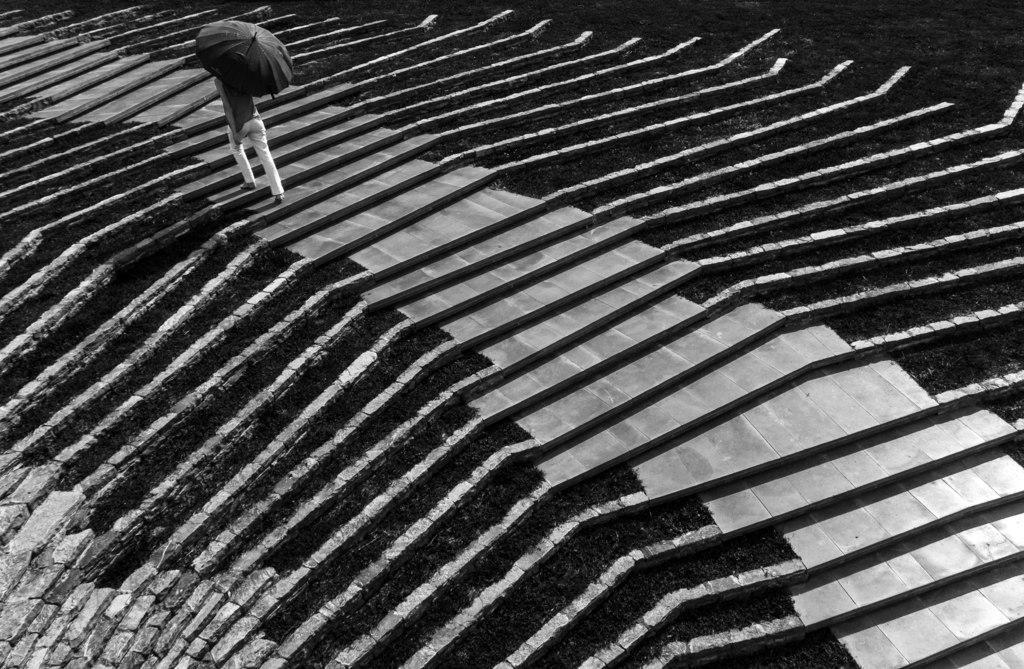Describe this image in one or two sentences. In this image there is a person holding an umbrella is climbing stairs. 